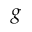Convert formula to latex. <formula><loc_0><loc_0><loc_500><loc_500>g</formula> 